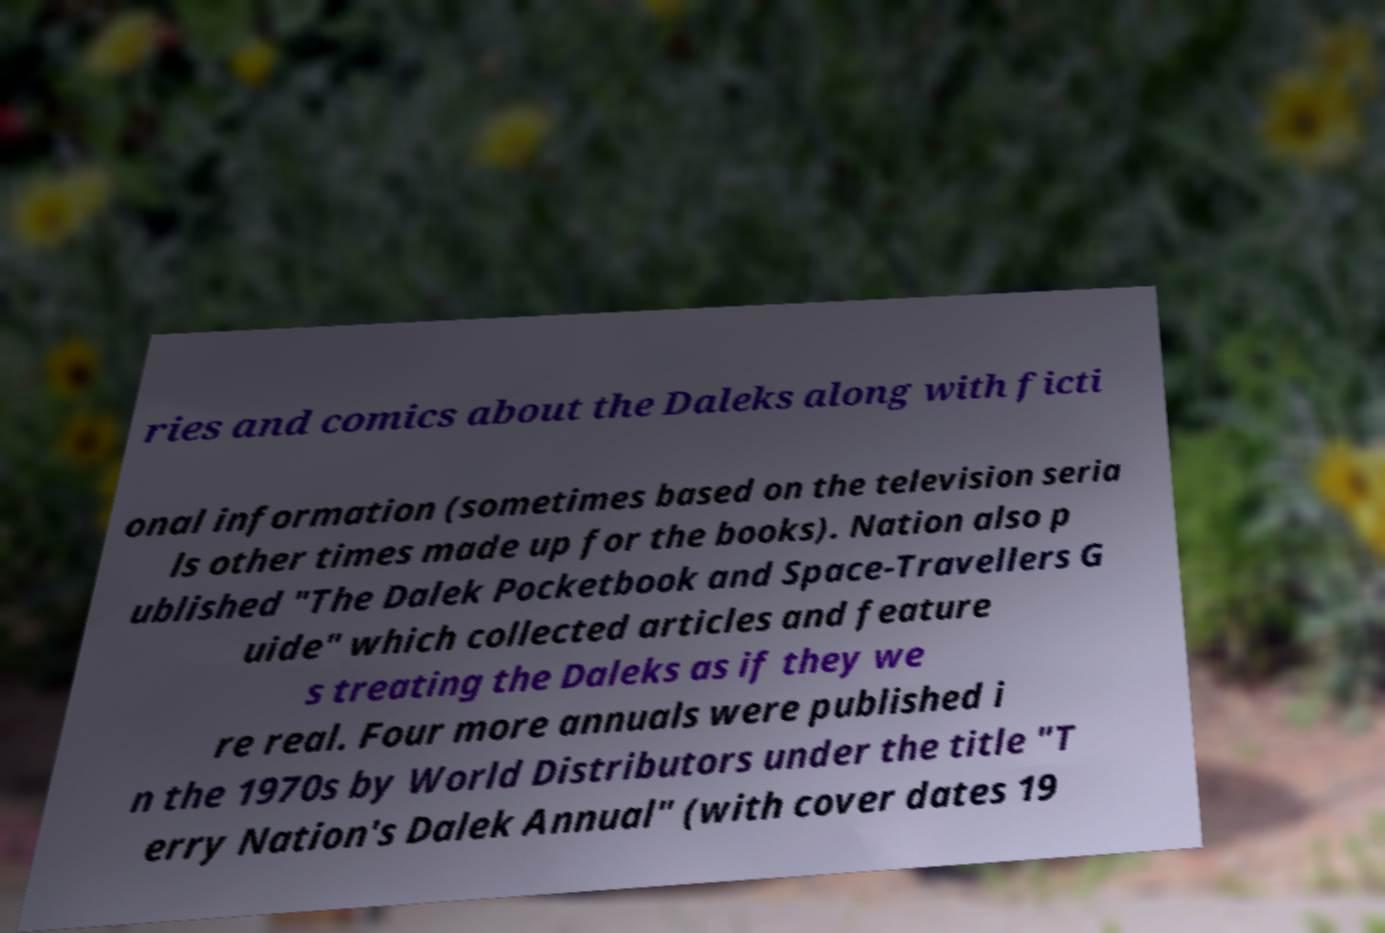For documentation purposes, I need the text within this image transcribed. Could you provide that? ries and comics about the Daleks along with ficti onal information (sometimes based on the television seria ls other times made up for the books). Nation also p ublished "The Dalek Pocketbook and Space-Travellers G uide" which collected articles and feature s treating the Daleks as if they we re real. Four more annuals were published i n the 1970s by World Distributors under the title "T erry Nation's Dalek Annual" (with cover dates 19 